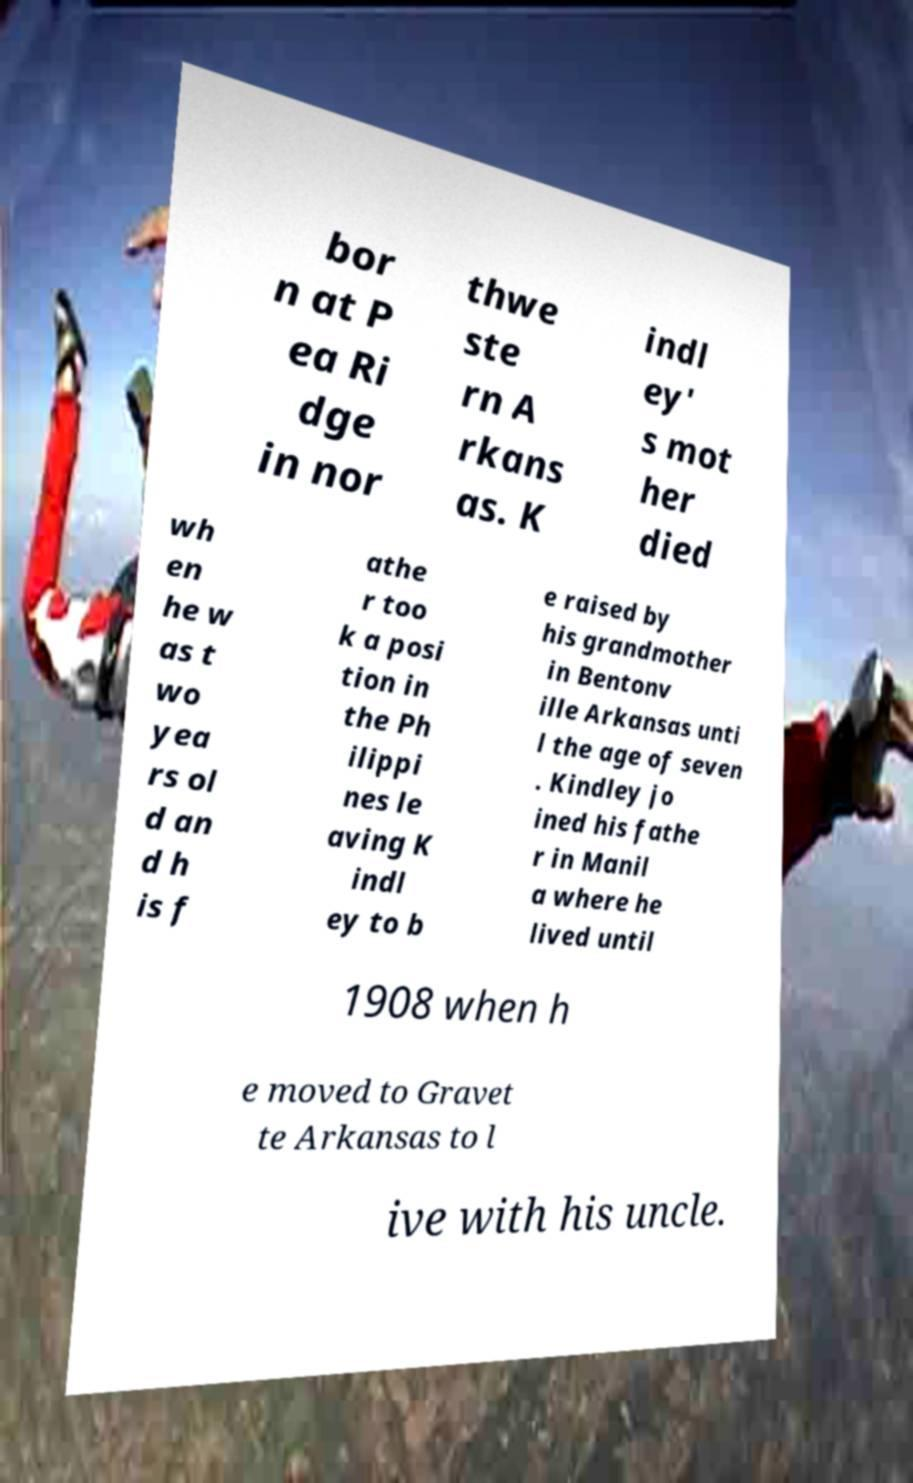Could you extract and type out the text from this image? bor n at P ea Ri dge in nor thwe ste rn A rkans as. K indl ey' s mot her died wh en he w as t wo yea rs ol d an d h is f athe r too k a posi tion in the Ph ilippi nes le aving K indl ey to b e raised by his grandmother in Bentonv ille Arkansas unti l the age of seven . Kindley jo ined his fathe r in Manil a where he lived until 1908 when h e moved to Gravet te Arkansas to l ive with his uncle. 